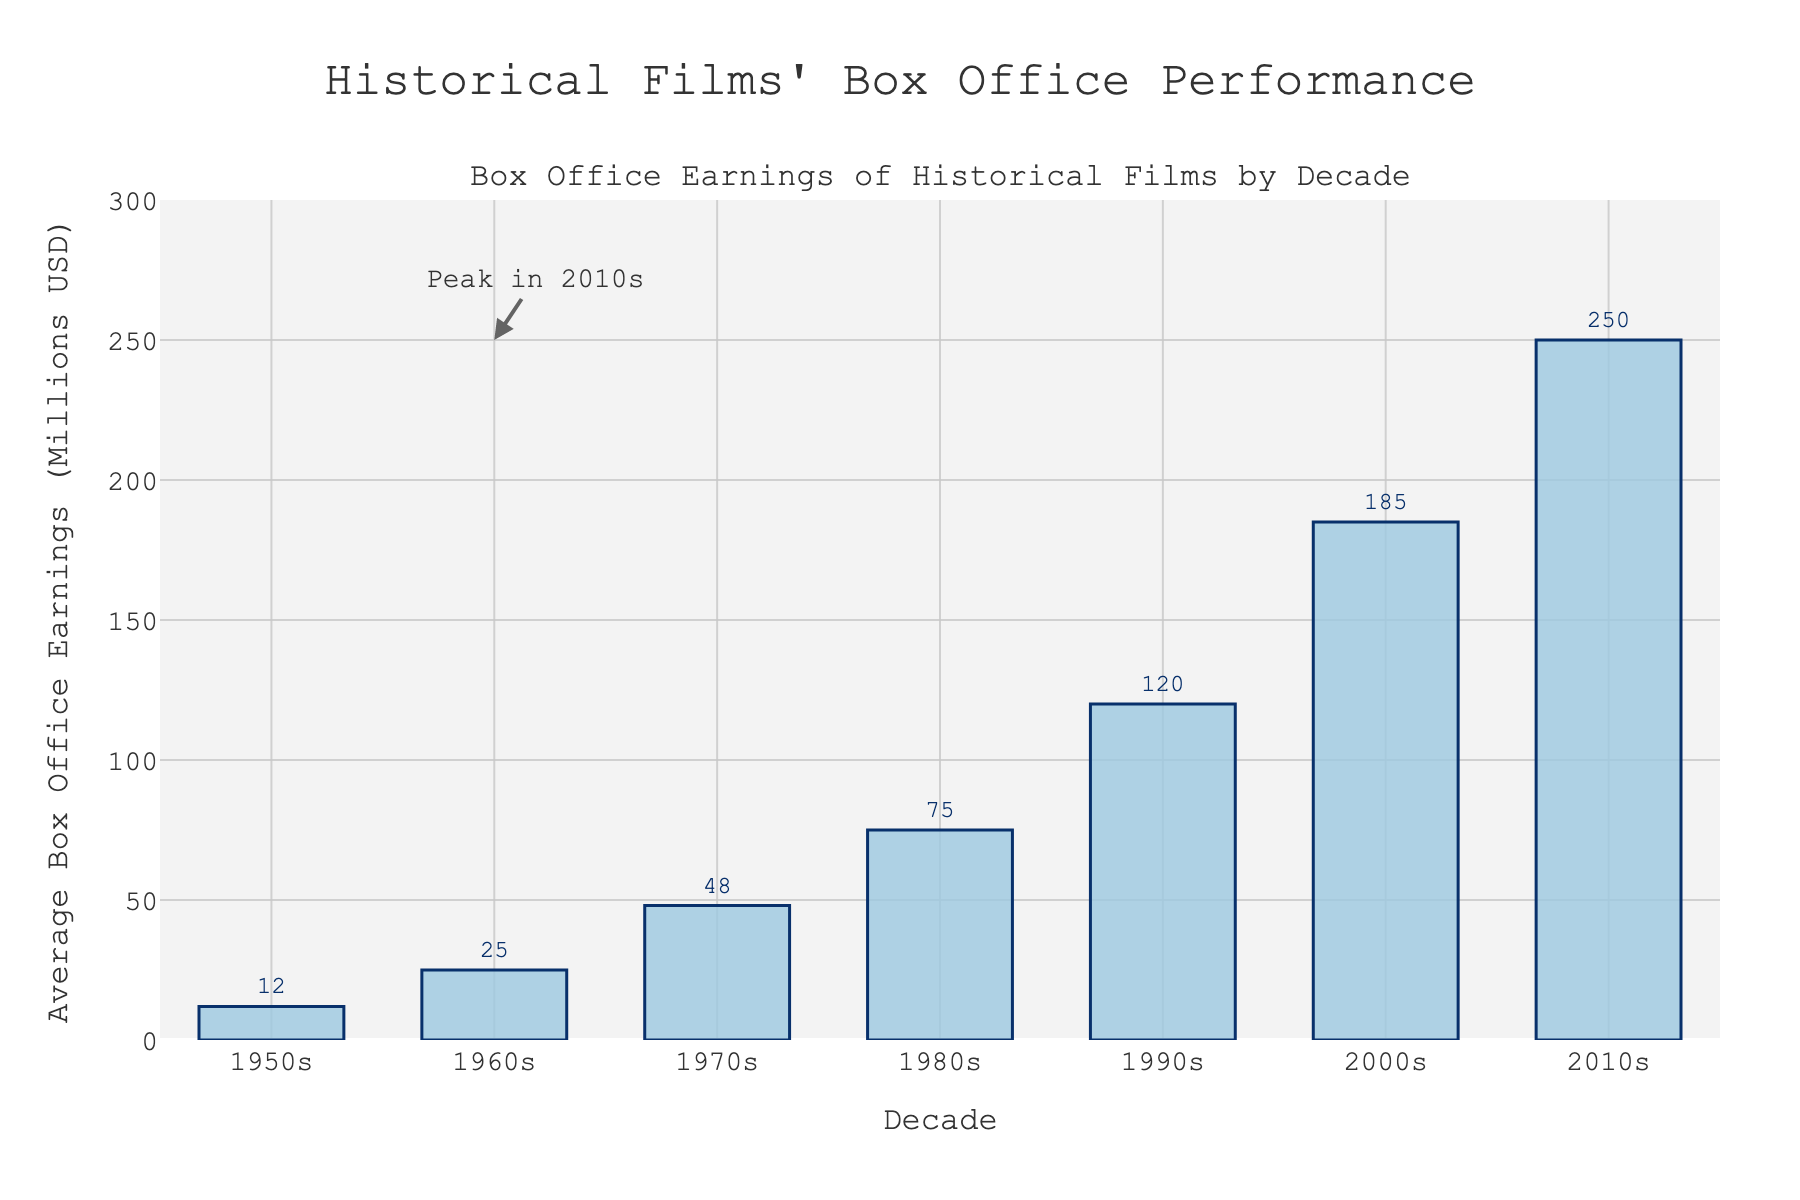How has the average box office earnings of historical films changed from the 1950s to the 2010s? The average box office earnings have increased steadily over the decades, starting at 12 million USD in the 1950s and reaching 250 million USD in the 2010s
Answer: Increased What's the average increase in box office earnings per decade from the 1950s to the 2010s? To find the average increase, calculate the difference in earnings between each consecutive decade and then find the mean of those differences: (25-12) + (48-25) + (75-48) + (120-75) + (185-120) + (250-185) = 13 + 23 + 27 + 45 + 65 + 65 = 238. Divide by 6 changes: 238 / 6 = 39.67 million USD
Answer: 39.67 million USD Which decade saw the largest increase in average box office earnings for historical films? The largest increase is observed between the 2000s and the 2010s, where the earnings jumped from 185 million USD to 250 million USD, an increase of 65 million USD
Answer: 2010s How do the box office earnings in the 1980s compare to those in the 1970s? The box office earnings in the 1980s were 75 million USD, whereas in the 1970s they were 48 million USD. Thus, the earnings in the 1980s were higher by 27 million USD
Answer: Higher by 27 million USD What is the percentage increase in average box office earnings from the 1990s to the 2000s? The increase from the 1990s (120 million USD) to the 2000s (185 million USD) is 65 million USD. To find the percentage increase: (65 / 120) * 100 ≈ 54.17%
Answer: 54.17% Which decade had the smallest box office earnings, and what was the amount? The 1950s had the smallest box office earnings, amounting to 12 million USD
Answer: 1950s, 12 million USD If you sum the box office earnings from the 1950s, 1960s, and 1970s, what is the total? Add the earnings for each of these decades: 12 + 25 + 48 = 85 million USD
Answer: 85 million USD How much more did historical films earn on average in the 2010s compared to the 1950s? The earnings in the 1950s were 12 million USD and in the 2010s were 250 million USD. The difference is 250 - 12 = 238 million USD
Answer: 238 million USD What do the annotations in the figure indicate? The annotations highlight that the peak of average box office earnings for historical films occurred in the 2010s
Answer: Peak in 2010s Is there any decade where the average box office earnings remained the same or decreased compared to the previous decade? Every decade saw an increase in average box office earnings compared to the previous one; hence, there is no decade where the earnings remained the same or decreased.
Answer: No 